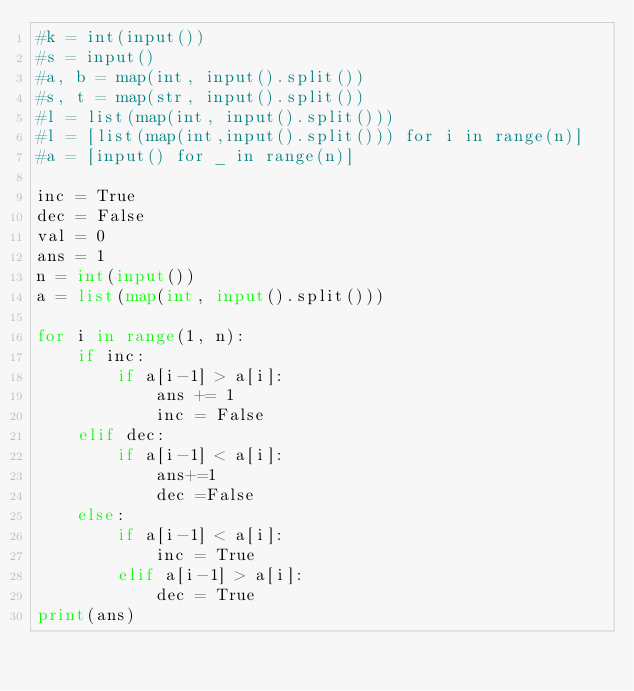<code> <loc_0><loc_0><loc_500><loc_500><_Python_>#k = int(input())
#s = input()
#a, b = map(int, input().split())
#s, t = map(str, input().split())
#l = list(map(int, input().split()))
#l = [list(map(int,input().split())) for i in range(n)]
#a = [input() for _ in range(n)]

inc = True
dec = False
val = 0
ans = 1
n = int(input())
a = list(map(int, input().split()))

for i in range(1, n):
    if inc:
        if a[i-1] > a[i]:
            ans += 1
            inc = False
    elif dec:
        if a[i-1] < a[i]:
            ans+=1
            dec =False
    else:
        if a[i-1] < a[i]:
            inc = True
        elif a[i-1] > a[i]:
            dec = True
print(ans)


</code> 